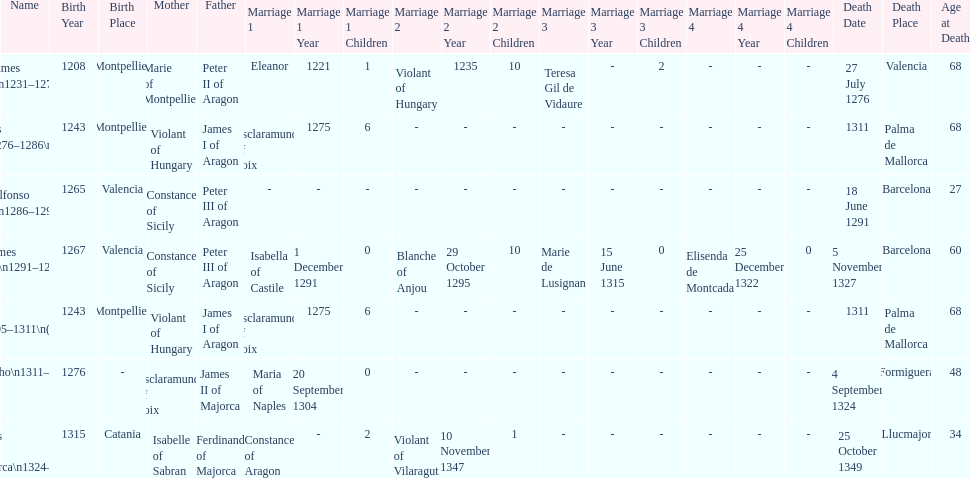Parse the table in full. {'header': ['Name', 'Birth Year', 'Birth Place', 'Mother', 'Father', 'Marriage 1', 'Marriage 1 Year', 'Marriage 1 Children', 'Marriage 2', 'Marriage 2 Year', 'Marriage 2 Children', 'Marriage 3', 'Marriage 3 Year', 'Marriage 3 Children', 'Marriage 4', 'Marriage 4 Year', 'Marriage 4 Children', 'Death Date', 'Death Place', 'Age at Death'], 'rows': [['James I\\n1231–1276', '1208', 'Montpellier', 'Marie of Montpellier', 'Peter II of Aragon', 'Eleanor', '1221', '1', 'Violant of Hungary', '1235', '10', 'Teresa Gil de Vidaure', '-', '2', '-', '-', '-', '27 July 1276', 'Valencia', '68'], ['James II\\n1276–1286\\n(first rule)', '1243', 'Montpellier', 'Violant of Hungary', 'James I of Aragon', 'Esclaramunda of Foix', '1275', '6', '-', '-', '-', '-', '-', '-', '-', '-', '-', '1311', 'Palma de Mallorca', '68'], ['Alfonso I\\n1286–1291', '1265', 'Valencia', 'Constance of Sicily', 'Peter III of Aragon', '-', '-', '-', '-', '-', '-', '-', '-', '-', '-', '-', '-', '18 June 1291', 'Barcelona', '27'], ['James III\\n1291–1295', '1267', 'Valencia', 'Constance of Sicily', 'Peter III of Aragon', 'Isabella of Castile', '1 December 1291', '0', 'Blanche of Anjou', '29 October 1295', '10', 'Marie de Lusignan', '15 June 1315', '0', 'Elisenda de Montcada', '25 December 1322', '0', '5 November 1327', 'Barcelona', '60'], ['James II\\n1295–1311\\n(second rule)', '1243', 'Montpellier', 'Violant of Hungary', 'James I of Aragon', 'Esclaramunda of Foix', '1275', '6', '-', '-', '-', '-', '-', '-', '-', '-', '-', '1311', 'Palma de Mallorca', '68'], ['Sancho\\n1311–1324', '1276', '-', 'Esclaramunda of Foix', 'James II of Majorca', 'Maria of Naples', '20 September 1304', '0', '-', '-', '-', '-', '-', '-', '-', '-', '-', '4 September 1324', 'Formiguera', '48'], ['James III of Majorca\\n1324–1344', '1315', 'Catania', 'Isabelle of Sabran', 'Ferdinand of Majorca', 'Constance of Aragon', '-', '2', 'Violant of Vilaragut', '10 November 1347', '1', '-', '-', '-', '-', '-', '-', '25 October 1349', 'Llucmajor', '34']]} Which two monarchs had no children? Alfonso I, Sancho. 